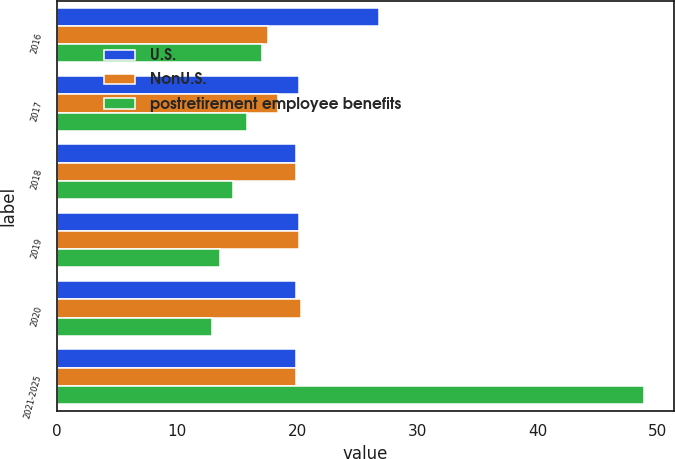Convert chart. <chart><loc_0><loc_0><loc_500><loc_500><stacked_bar_chart><ecel><fcel>2016<fcel>2017<fcel>2018<fcel>2019<fcel>2020<fcel>2021-2025<nl><fcel>U.S.<fcel>26.8<fcel>20.2<fcel>19.9<fcel>20.2<fcel>19.9<fcel>19.9<nl><fcel>NonU.S.<fcel>17.6<fcel>18.4<fcel>19.9<fcel>20.2<fcel>20.3<fcel>19.9<nl><fcel>postretirement employee benefits<fcel>17.1<fcel>15.8<fcel>14.7<fcel>13.6<fcel>12.9<fcel>48.9<nl></chart> 